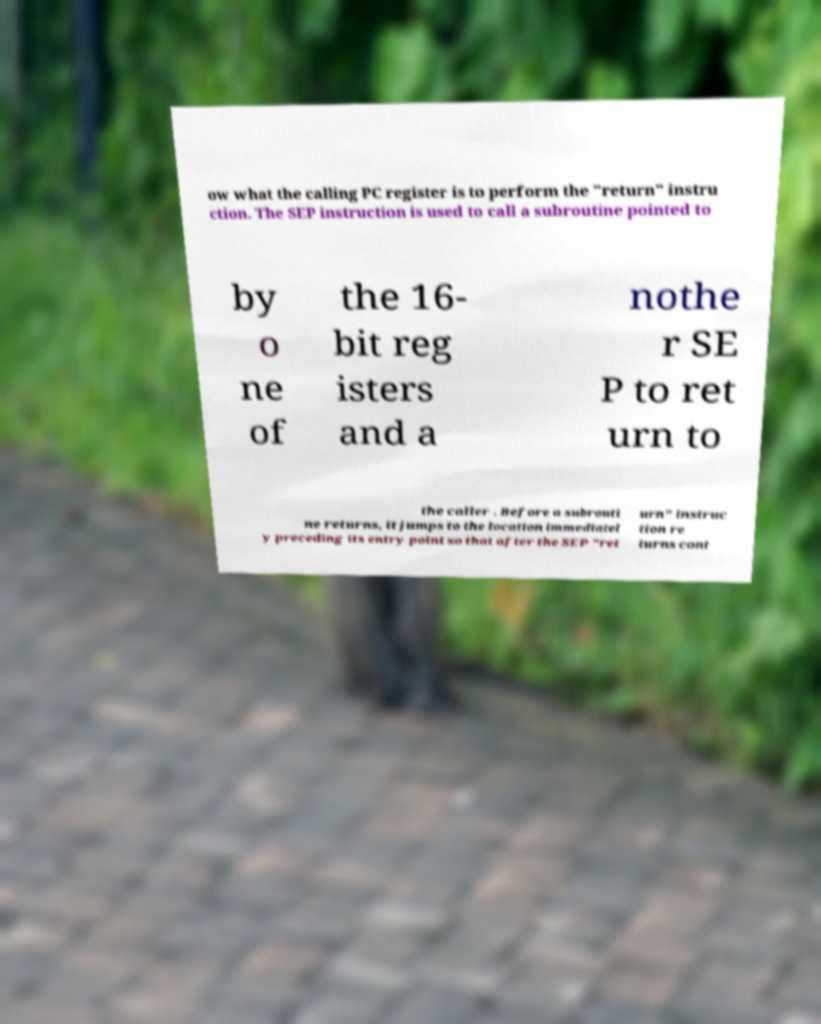What messages or text are displayed in this image? I need them in a readable, typed format. ow what the calling PC register is to perform the "return" instru ction. The SEP instruction is used to call a subroutine pointed to by o ne of the 16- bit reg isters and a nothe r SE P to ret urn to the caller . Before a subrouti ne returns, it jumps to the location immediatel y preceding its entry point so that after the SEP "ret urn" instruc tion re turns cont 